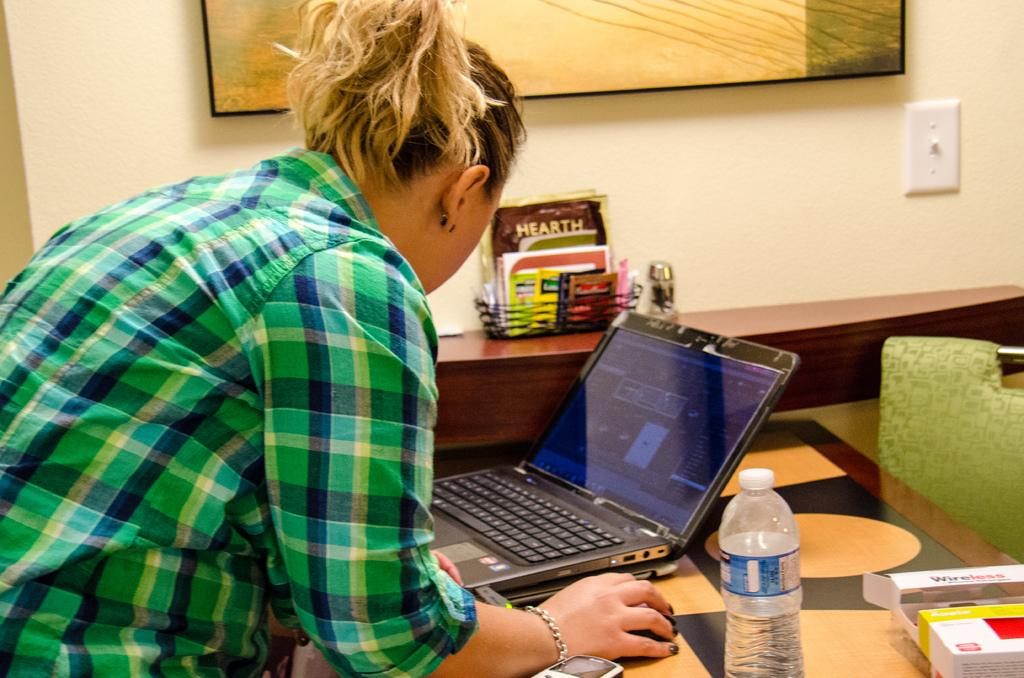What is the woman doing in the image? The woman is standing in a room. What furniture is present in the room? There is a table in the room. What electronic devices are on the table? There is a laptop, a book, and a mobile phone on the table. What can be seen in the background of the image? There is a photo frame and a wall visible in the background. What direction is the woman facing in the image? The image does not provide information about the direction the woman is facing. What type of voyage is the woman planning based on the items on the table? There is no information in the image to suggest that the woman is planning a voyage or that the items on the table are related to a voyage. 